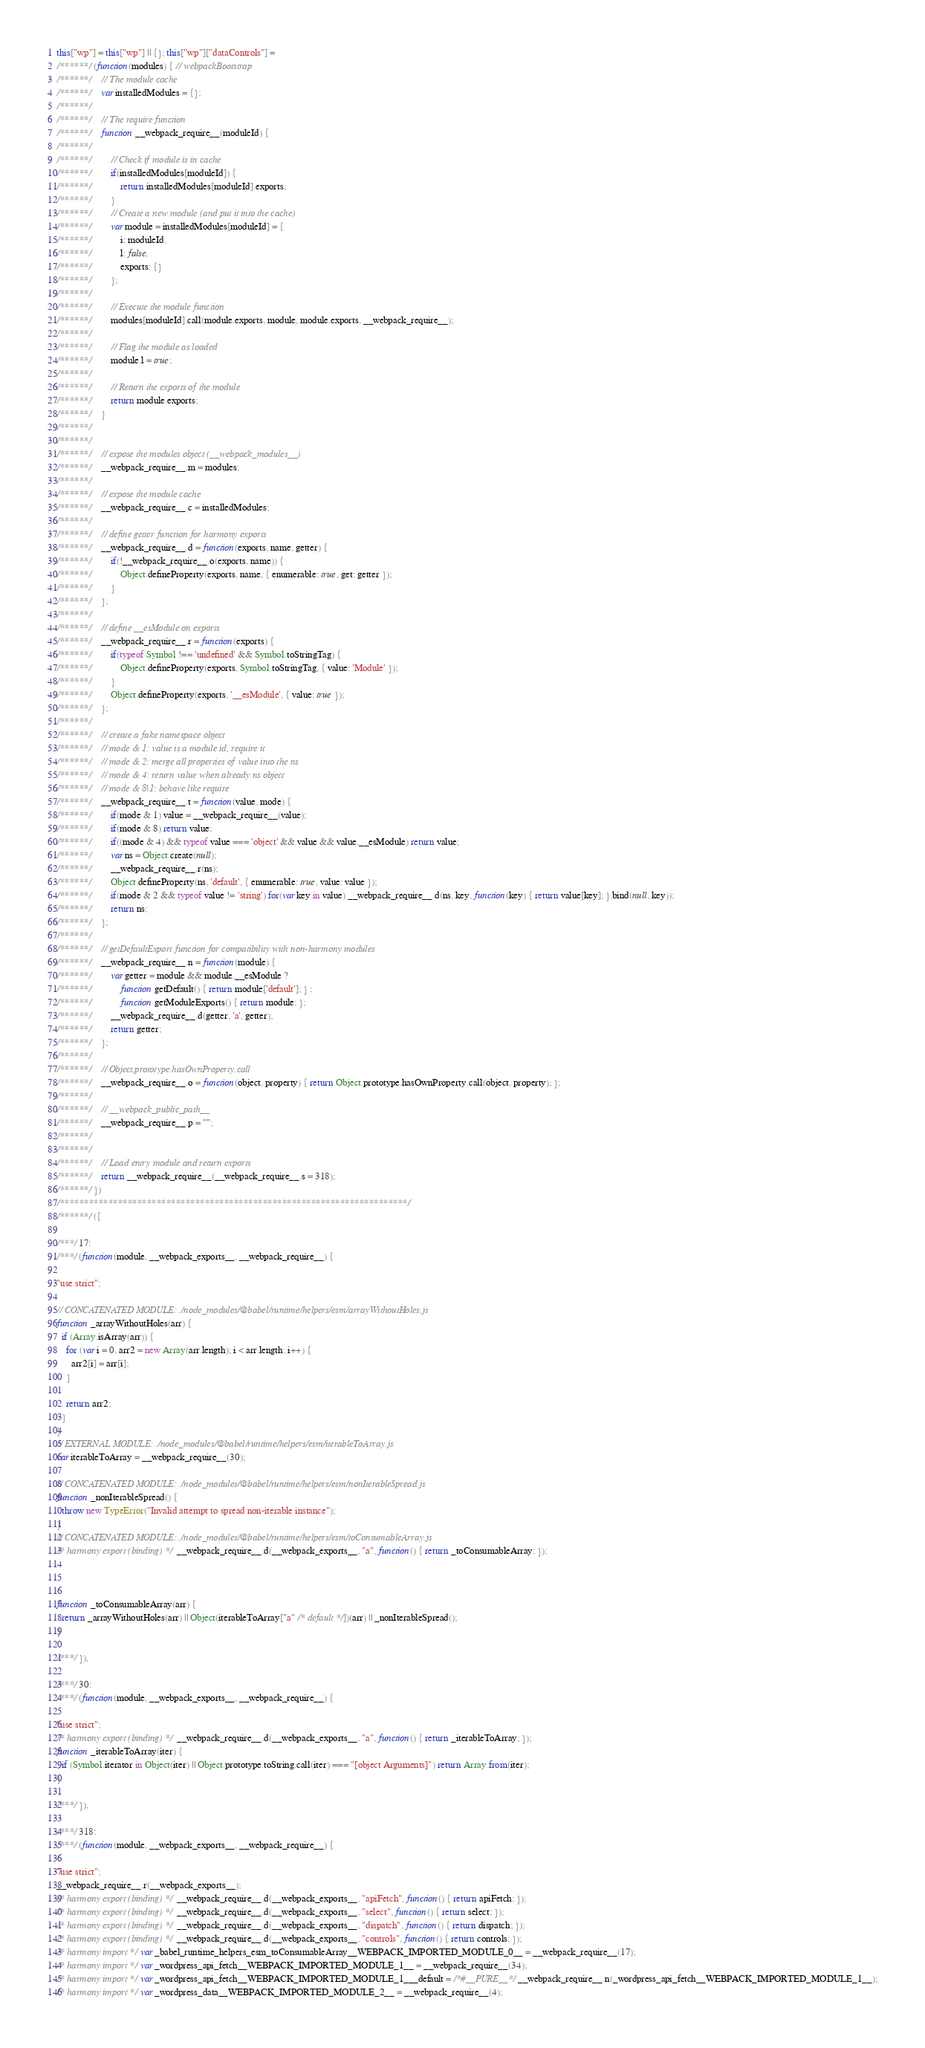<code> <loc_0><loc_0><loc_500><loc_500><_JavaScript_>this["wp"] = this["wp"] || {}; this["wp"]["dataControls"] =
/******/ (function(modules) { // webpackBootstrap
/******/ 	// The module cache
/******/ 	var installedModules = {};
/******/
/******/ 	// The require function
/******/ 	function __webpack_require__(moduleId) {
/******/
/******/ 		// Check if module is in cache
/******/ 		if(installedModules[moduleId]) {
/******/ 			return installedModules[moduleId].exports;
/******/ 		}
/******/ 		// Create a new module (and put it into the cache)
/******/ 		var module = installedModules[moduleId] = {
/******/ 			i: moduleId,
/******/ 			l: false,
/******/ 			exports: {}
/******/ 		};
/******/
/******/ 		// Execute the module function
/******/ 		modules[moduleId].call(module.exports, module, module.exports, __webpack_require__);
/******/
/******/ 		// Flag the module as loaded
/******/ 		module.l = true;
/******/
/******/ 		// Return the exports of the module
/******/ 		return module.exports;
/******/ 	}
/******/
/******/
/******/ 	// expose the modules object (__webpack_modules__)
/******/ 	__webpack_require__.m = modules;
/******/
/******/ 	// expose the module cache
/******/ 	__webpack_require__.c = installedModules;
/******/
/******/ 	// define getter function for harmony exports
/******/ 	__webpack_require__.d = function(exports, name, getter) {
/******/ 		if(!__webpack_require__.o(exports, name)) {
/******/ 			Object.defineProperty(exports, name, { enumerable: true, get: getter });
/******/ 		}
/******/ 	};
/******/
/******/ 	// define __esModule on exports
/******/ 	__webpack_require__.r = function(exports) {
/******/ 		if(typeof Symbol !== 'undefined' && Symbol.toStringTag) {
/******/ 			Object.defineProperty(exports, Symbol.toStringTag, { value: 'Module' });
/******/ 		}
/******/ 		Object.defineProperty(exports, '__esModule', { value: true });
/******/ 	};
/******/
/******/ 	// create a fake namespace object
/******/ 	// mode & 1: value is a module id, require it
/******/ 	// mode & 2: merge all properties of value into the ns
/******/ 	// mode & 4: return value when already ns object
/******/ 	// mode & 8|1: behave like require
/******/ 	__webpack_require__.t = function(value, mode) {
/******/ 		if(mode & 1) value = __webpack_require__(value);
/******/ 		if(mode & 8) return value;
/******/ 		if((mode & 4) && typeof value === 'object' && value && value.__esModule) return value;
/******/ 		var ns = Object.create(null);
/******/ 		__webpack_require__.r(ns);
/******/ 		Object.defineProperty(ns, 'default', { enumerable: true, value: value });
/******/ 		if(mode & 2 && typeof value != 'string') for(var key in value) __webpack_require__.d(ns, key, function(key) { return value[key]; }.bind(null, key));
/******/ 		return ns;
/******/ 	};
/******/
/******/ 	// getDefaultExport function for compatibility with non-harmony modules
/******/ 	__webpack_require__.n = function(module) {
/******/ 		var getter = module && module.__esModule ?
/******/ 			function getDefault() { return module['default']; } :
/******/ 			function getModuleExports() { return module; };
/******/ 		__webpack_require__.d(getter, 'a', getter);
/******/ 		return getter;
/******/ 	};
/******/
/******/ 	// Object.prototype.hasOwnProperty.call
/******/ 	__webpack_require__.o = function(object, property) { return Object.prototype.hasOwnProperty.call(object, property); };
/******/
/******/ 	// __webpack_public_path__
/******/ 	__webpack_require__.p = "";
/******/
/******/
/******/ 	// Load entry module and return exports
/******/ 	return __webpack_require__(__webpack_require__.s = 318);
/******/ })
/************************************************************************/
/******/ ({

/***/ 17:
/***/ (function(module, __webpack_exports__, __webpack_require__) {

"use strict";

// CONCATENATED MODULE: ./node_modules/@babel/runtime/helpers/esm/arrayWithoutHoles.js
function _arrayWithoutHoles(arr) {
  if (Array.isArray(arr)) {
    for (var i = 0, arr2 = new Array(arr.length); i < arr.length; i++) {
      arr2[i] = arr[i];
    }

    return arr2;
  }
}
// EXTERNAL MODULE: ./node_modules/@babel/runtime/helpers/esm/iterableToArray.js
var iterableToArray = __webpack_require__(30);

// CONCATENATED MODULE: ./node_modules/@babel/runtime/helpers/esm/nonIterableSpread.js
function _nonIterableSpread() {
  throw new TypeError("Invalid attempt to spread non-iterable instance");
}
// CONCATENATED MODULE: ./node_modules/@babel/runtime/helpers/esm/toConsumableArray.js
/* harmony export (binding) */ __webpack_require__.d(__webpack_exports__, "a", function() { return _toConsumableArray; });



function _toConsumableArray(arr) {
  return _arrayWithoutHoles(arr) || Object(iterableToArray["a" /* default */])(arr) || _nonIterableSpread();
}

/***/ }),

/***/ 30:
/***/ (function(module, __webpack_exports__, __webpack_require__) {

"use strict";
/* harmony export (binding) */ __webpack_require__.d(__webpack_exports__, "a", function() { return _iterableToArray; });
function _iterableToArray(iter) {
  if (Symbol.iterator in Object(iter) || Object.prototype.toString.call(iter) === "[object Arguments]") return Array.from(iter);
}

/***/ }),

/***/ 318:
/***/ (function(module, __webpack_exports__, __webpack_require__) {

"use strict";
__webpack_require__.r(__webpack_exports__);
/* harmony export (binding) */ __webpack_require__.d(__webpack_exports__, "apiFetch", function() { return apiFetch; });
/* harmony export (binding) */ __webpack_require__.d(__webpack_exports__, "select", function() { return select; });
/* harmony export (binding) */ __webpack_require__.d(__webpack_exports__, "dispatch", function() { return dispatch; });
/* harmony export (binding) */ __webpack_require__.d(__webpack_exports__, "controls", function() { return controls; });
/* harmony import */ var _babel_runtime_helpers_esm_toConsumableArray__WEBPACK_IMPORTED_MODULE_0__ = __webpack_require__(17);
/* harmony import */ var _wordpress_api_fetch__WEBPACK_IMPORTED_MODULE_1__ = __webpack_require__(34);
/* harmony import */ var _wordpress_api_fetch__WEBPACK_IMPORTED_MODULE_1___default = /*#__PURE__*/__webpack_require__.n(_wordpress_api_fetch__WEBPACK_IMPORTED_MODULE_1__);
/* harmony import */ var _wordpress_data__WEBPACK_IMPORTED_MODULE_2__ = __webpack_require__(4);</code> 